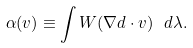<formula> <loc_0><loc_0><loc_500><loc_500>\alpha ( v ) \equiv \int W ( \nabla d \cdot v ) \ d \lambda .</formula> 